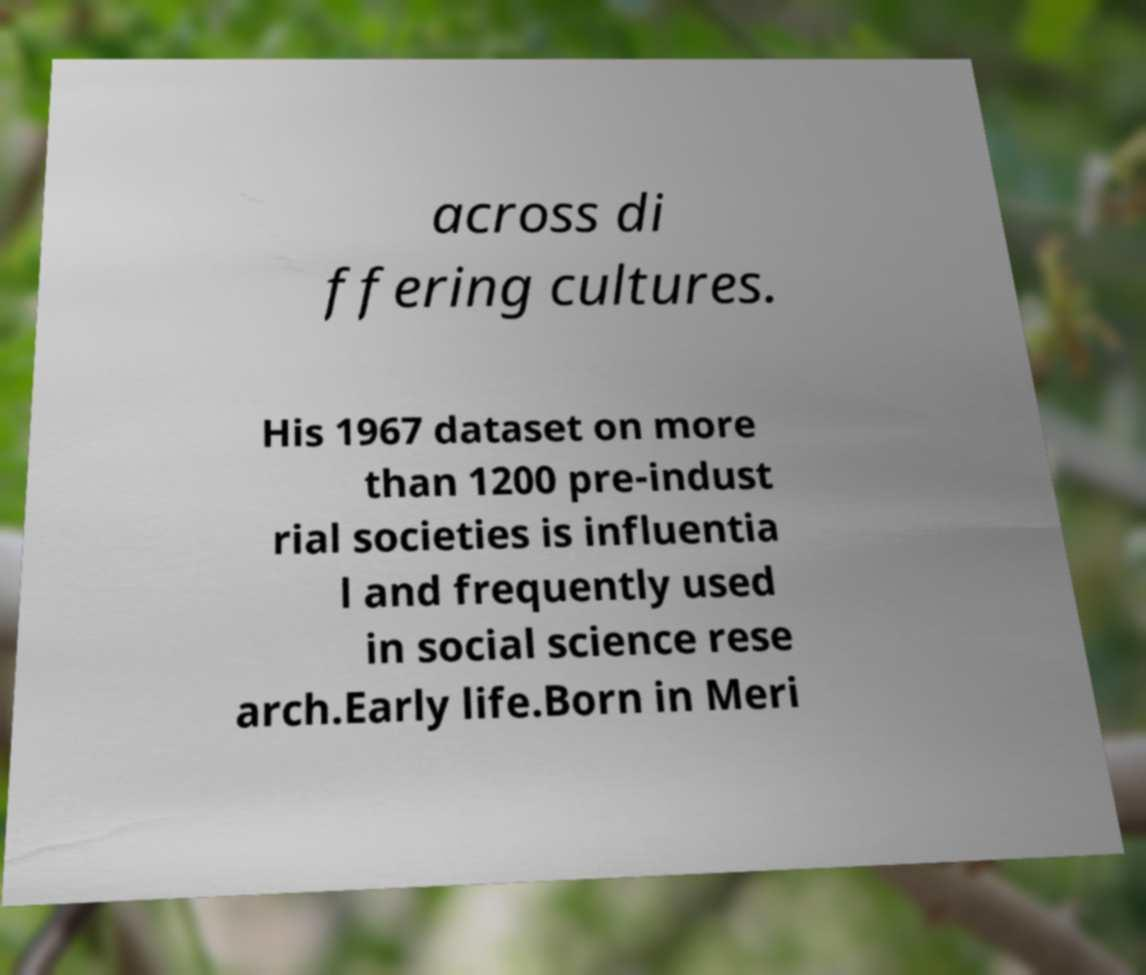I need the written content from this picture converted into text. Can you do that? across di ffering cultures. His 1967 dataset on more than 1200 pre-indust rial societies is influentia l and frequently used in social science rese arch.Early life.Born in Meri 